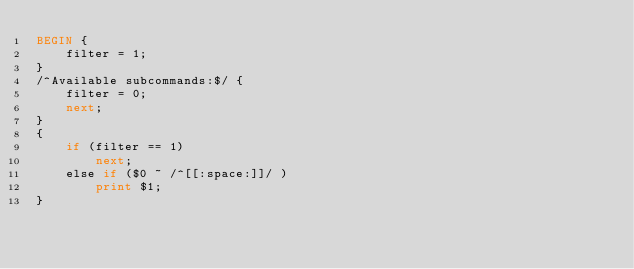<code> <loc_0><loc_0><loc_500><loc_500><_Awk_>BEGIN {
	filter = 1;
}
/^Available subcommands:$/ {
	filter = 0;
	next;
}
{
	if (filter == 1)
		next;
	else if ($0 ~ /^[[:space:]]/ )
		print $1;
}
</code> 